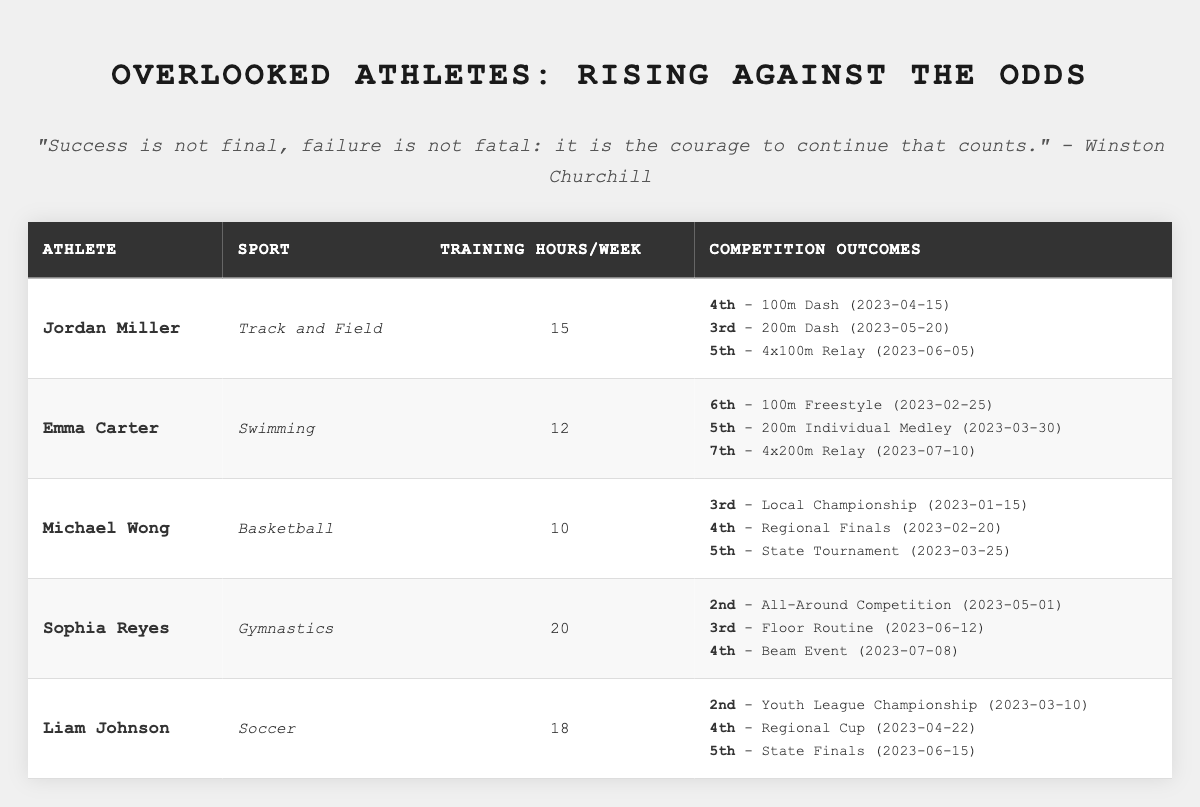What sport does Jordan Miller compete in? Jordan Miller's sport is listed in the table under the 'Sport' column, which shows he competes in Track and Field.
Answer: Track and Field How many training hours does Sophia Reyes put in each week? The table shows Sophia Reyes's training hours per week in the 'Training Hours/Week' column, which is indicated as 20 hours.
Answer: 20 Which athlete finished in 2nd place in their competition? Upon reviewing the 'Competition Outcomes' for all athletes, Sophia Reyes finished 2nd in the All-Around Competition.
Answer: Sophia Reyes What was the average training hours per week for the athletes listed? Adding the training hours: (15 + 12 + 10 + 20 + 18) = 75. There are 5 athletes, so the average is 75/5 = 15.
Answer: 15 Did Emma Carter achieve any positions higher than 5th in her competitions? Looking at Emma Carter's competition outcomes, none of her positions are higher than 5th; her highest was 5th in both of her events.
Answer: No Who had the lowest training hours per week, and what is the amount? By examining the training hours column, Michael Wong has the lowest training hours at 10 per week.
Answer: Michael Wong, 10 What position did Liam Johnson secure in the Youth League Championship? The table indicates that Liam Johnson secured the 2nd position in the Youth League Championship.
Answer: 2nd How many athletes achieved a podium position (top 3) in their events? Reviewing the competition outcomes, only Jordan Miller, Sophia Reyes, and Liam Johnson secured podium positions (1st, 2nd, or 3rd) in their events. Counting those, three athletes achieved podium finishes.
Answer: 3 What is the total number of competitions the athletes participated in? Counting all the competition outcomes listed, each athlete participated in 3 events: 5 athletes x 3 events = 15 competitions in total.
Answer: 15 Which athlete trained more hours than Emma Carter and finished higher than 5th in any event? Sophia Reyes trained for 20 hours and had multiple finishes higher than 5th. Checking each athlete, only Sophia Reyes meets both criteria.
Answer: Sophia Reyes 